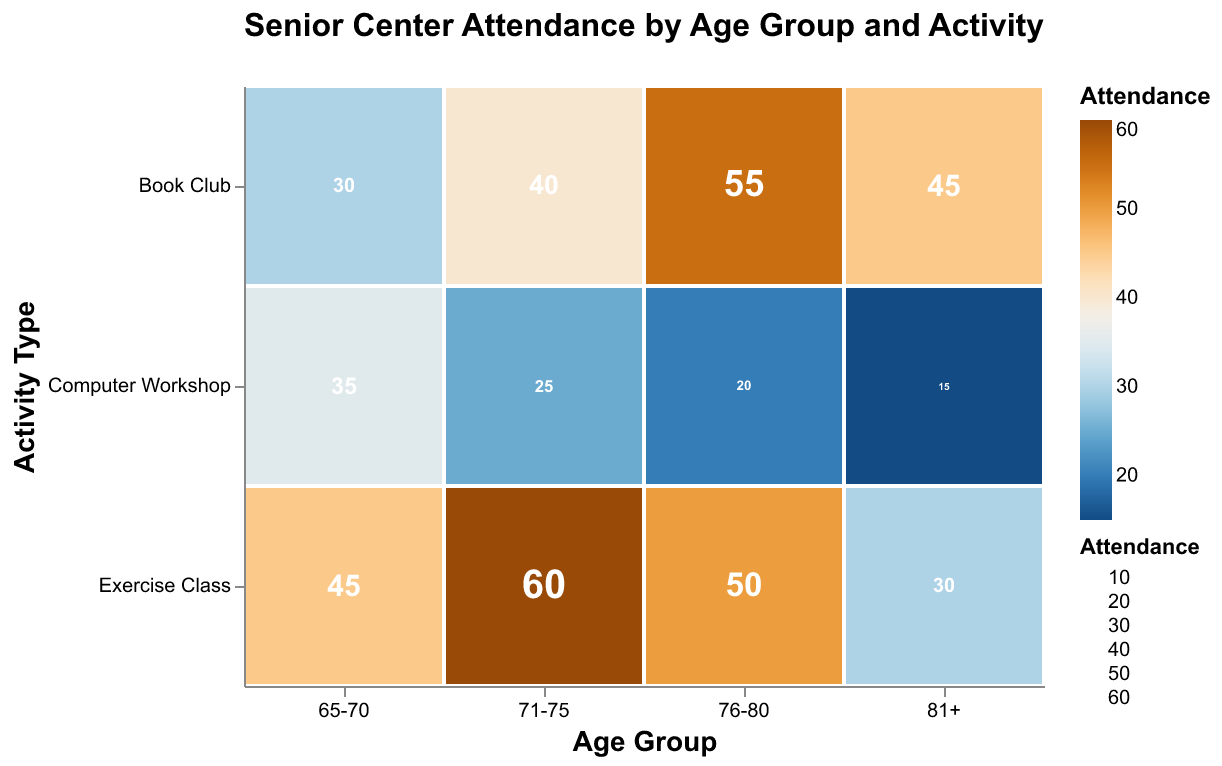What's the title of the figure? The title of the figure is displayed at the top and it is bolded and centered. The title reads "Senior Center Attendance by Age Group and Activity".
Answer: Senior Center Attendance by Age Group and Activity Which activity has the highest attendance in the 71-75 age group? To determine the activity with the highest attendance for the 71-75 age group, look at the blue-orange ratio in the rectangles for this age group. The rectangle for "Exercise Class" has the darkest color, indicating the highest attendance (60).
Answer: Exercise Class What's the total attendance across all activities for the age group 81+? Sum the attendance values for all activities in the 81+ age group: Exercise Class (30) + Book Club (45) + Computer Workshop (15). 30 + 45 + 15 = 90.
Answer: 90 Which age group has the lowest attendance for Computer Workshops? Compare the Computer Workshop attendance values across all age groups. The lowest value is 15 for the age group 81+.
Answer: 81+ How does attendance for Book Club change with age? Analyze the color gradient and numbers corresponding to Book Club across different age groups. Attendance for Book Club starts at 30 for age 65-70, increases to 40 for age 71-75, peaks at 55 for age 76-80, and then decreases to 45 for age 81+.
Answer: It increases up to 76-80, then slightly decreases for 81+ Which age group participates most in exercise classes? Compare the attendance values for Exercise Classes across all age groups. The highest value is 60, seen in the age group 71-75.
Answer: 71-75 What's the average attendance for Computer Workshops across all age groups? To find the average attendance for Computer Workshops, sum the attendances and divide by the number of age groups: (35 + 25 + 20 + 15) / 4 = 95 / 4 = 23.75.
Answer: 23.75 What's the difference in Book Club attendance between the 76-80 and 65-70 age groups? Subtract the Book Club attendance for 65-70 from that of 76-80. 55 (76-80) - 30 (65-70) = 25.
Answer: 25 Which age group and activity combination has the absolute highest attendance? Scan the plot for the highest numerical value or the darkest box. The highest attendance is for Exercise Class in the 71-75 age group, with a value of 60.
Answer: 71-75, Exercise Class 